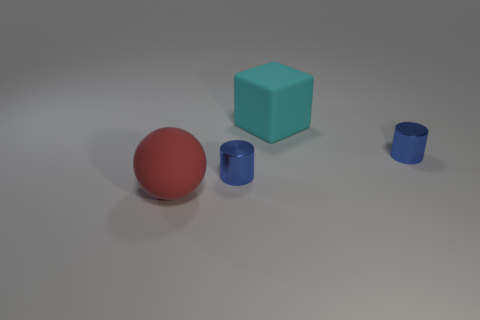There is a rubber thing on the right side of the big sphere; how many small blue objects are in front of it?
Your answer should be compact. 2. What number of big cyan things are made of the same material as the big red sphere?
Offer a very short reply. 1. There is a large block; are there any large matte objects right of it?
Offer a very short reply. No. What color is the matte block that is the same size as the red thing?
Ensure brevity in your answer.  Cyan. What number of objects are either big matte things to the right of the large sphere or tiny blue metal objects?
Ensure brevity in your answer.  3. What number of other objects are the same size as the cyan rubber block?
Your response must be concise. 1. What color is the small metallic cylinder that is to the left of the big rubber thing right of the big red object in front of the cyan rubber block?
Provide a succinct answer. Blue. The object that is behind the rubber sphere and left of the large block has what shape?
Make the answer very short. Cylinder. What number of other things are there of the same shape as the red matte object?
Provide a short and direct response. 0. What is the shape of the large rubber thing that is on the right side of the big red matte ball in front of the big rubber thing on the right side of the ball?
Your answer should be very brief. Cube. 